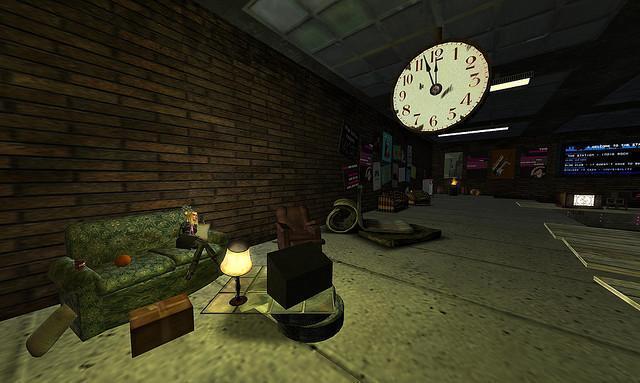How many clocks are in the photo?
Give a very brief answer. 1. 